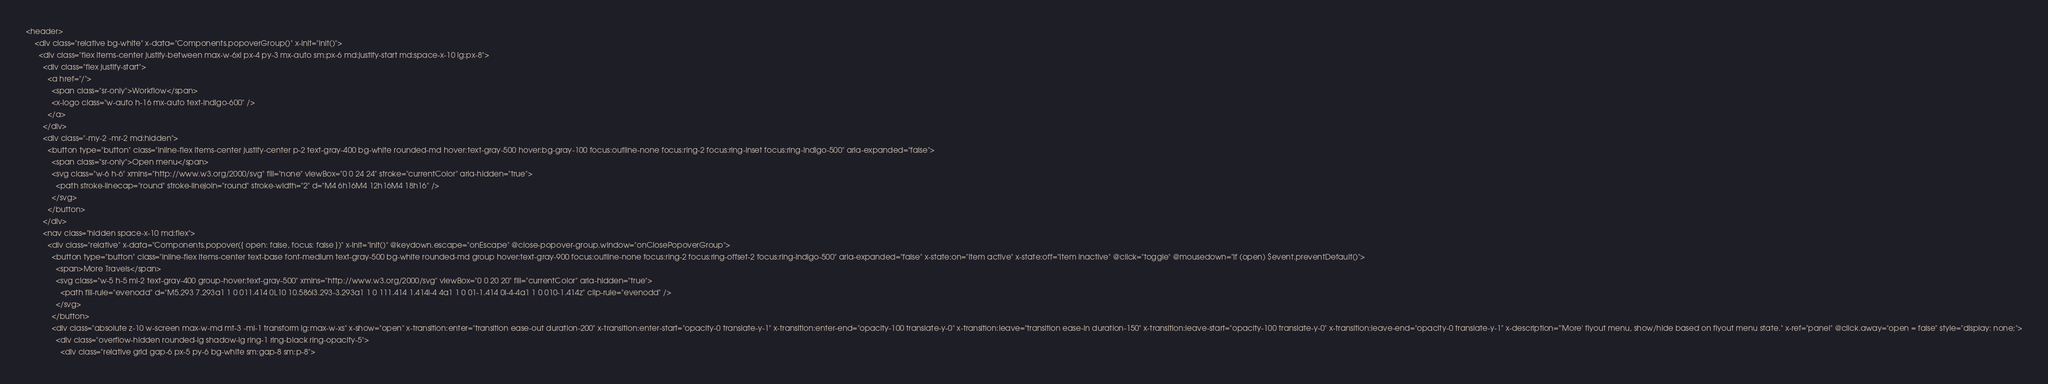<code> <loc_0><loc_0><loc_500><loc_500><_PHP_><header>
    <div class="relative bg-white" x-data="Components.popoverGroup()" x-init="init()">
      <div class="flex items-center justify-between max-w-6xl px-4 py-3 mx-auto sm:px-6 md:justify-start md:space-x-10 lg:px-8">
        <div class="flex justify-start">
          <a href="/">
            <span class="sr-only">Workflow</span>
            <x-logo class="w-auto h-16 mx-auto text-indigo-600" />
          </a>
        </div>
        <div class="-my-2 -mr-2 md:hidden">
          <button type="button" class="inline-flex items-center justify-center p-2 text-gray-400 bg-white rounded-md hover:text-gray-500 hover:bg-gray-100 focus:outline-none focus:ring-2 focus:ring-inset focus:ring-indigo-500" aria-expanded="false">
            <span class="sr-only">Open menu</span>
            <svg class="w-6 h-6" xmlns="http://www.w3.org/2000/svg" fill="none" viewBox="0 0 24 24" stroke="currentColor" aria-hidden="true">
              <path stroke-linecap="round" stroke-linejoin="round" stroke-width="2" d="M4 6h16M4 12h16M4 18h16" />
            </svg>
          </button>
        </div>
        <nav class="hidden space-x-10 md:flex">
          <div class="relative" x-data="Components.popover({ open: false, focus: false })" x-init="init()" @keydown.escape="onEscape" @close-popover-group.window="onClosePopoverGroup">
            <button type="button" class="inline-flex items-center text-base font-medium text-gray-500 bg-white rounded-md group hover:text-gray-900 focus:outline-none focus:ring-2 focus:ring-offset-2 focus:ring-indigo-500" aria-expanded="false" x-state:on="Item active" x-state:off="Item inactive" @click="toggle" @mousedown="if (open) $event.preventDefault()">
              <span>More Travels</span>
              <svg class="w-5 h-5 ml-2 text-gray-400 group-hover:text-gray-500" xmlns="http://www.w3.org/2000/svg" viewBox="0 0 20 20" fill="currentColor" aria-hidden="true">
                <path fill-rule="evenodd" d="M5.293 7.293a1 1 0 011.414 0L10 10.586l3.293-3.293a1 1 0 111.414 1.414l-4 4a1 1 0 01-1.414 0l-4-4a1 1 0 010-1.414z" clip-rule="evenodd" />
              </svg>
            </button>
            <div class="absolute z-10 w-screen max-w-md mt-3 -ml-1 transform lg:max-w-xs" x-show="open" x-transition:enter="transition ease-out duration-200" x-transition:enter-start="opacity-0 translate-y-1" x-transition:enter-end="opacity-100 translate-y-0" x-transition:leave="transition ease-in duration-150" x-transition:leave-start="opacity-100 translate-y-0" x-transition:leave-end="opacity-0 translate-y-1" x-description="'More' flyout menu, show/hide based on flyout menu state." x-ref="panel" @click.away="open = false" style="display: none;">
              <div class="overflow-hidden rounded-lg shadow-lg ring-1 ring-black ring-opacity-5">
                <div class="relative grid gap-6 px-5 py-6 bg-white sm:gap-8 sm:p-8"></code> 